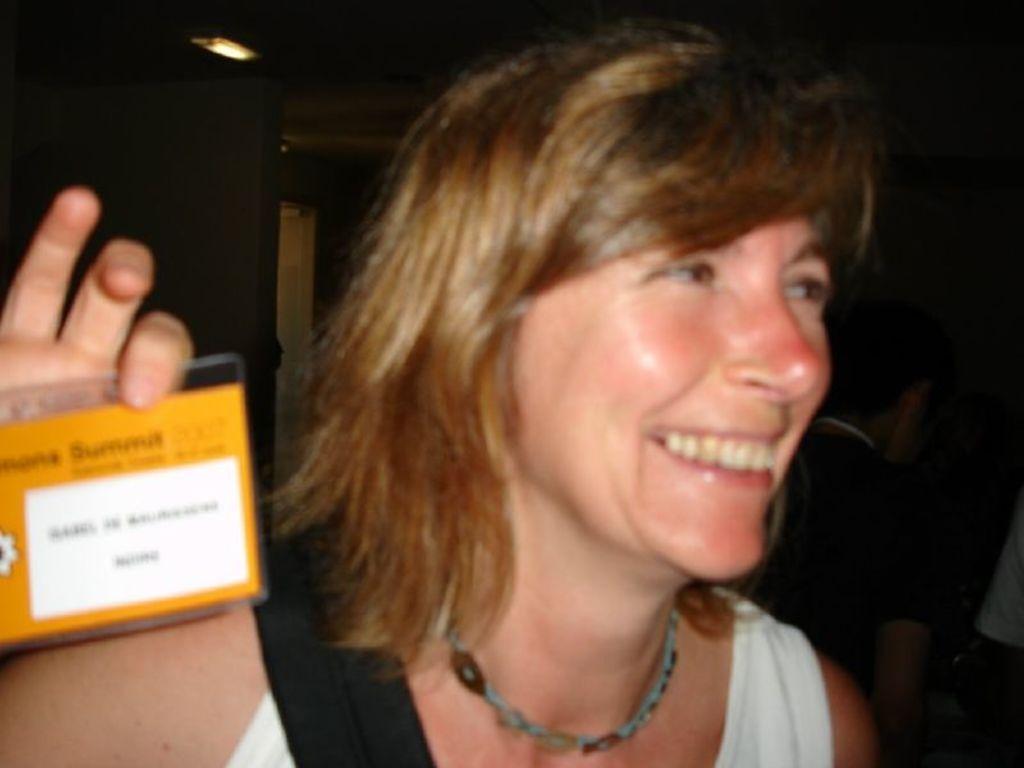Describe this image in one or two sentences. In this image there is a woman holding an ID card with a smile on her face. 